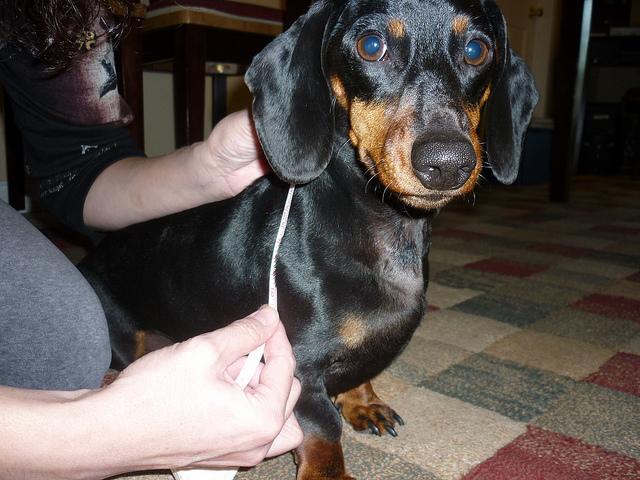What kind of animal is this?
Concise answer only. Dog. What color are the puppies eye?
Answer briefly. Brown. What type of dog is this?
Give a very brief answer. Dachshund. What is the person doing?
Keep it brief. Measuring dog. 